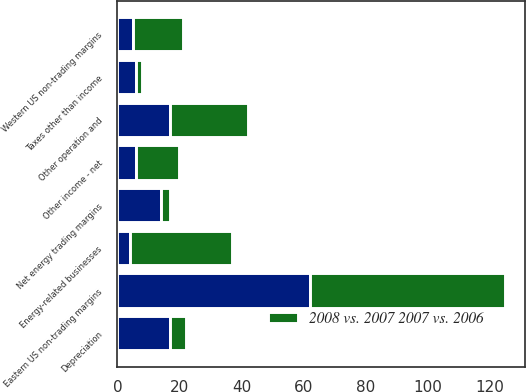Convert chart. <chart><loc_0><loc_0><loc_500><loc_500><stacked_bar_chart><ecel><fcel>Eastern US non-trading margins<fcel>Western US non-trading margins<fcel>Net energy trading margins<fcel>Energy-related businesses<fcel>Other operation and<fcel>Depreciation<fcel>Taxes other than income<fcel>Other income - net<nl><fcel>nan<fcel>62<fcel>5<fcel>14<fcel>4<fcel>17<fcel>17<fcel>6<fcel>6<nl><fcel>2008 vs. 2007 2007 vs. 2006<fcel>63<fcel>16<fcel>3<fcel>33<fcel>25<fcel>5<fcel>2<fcel>14<nl></chart> 